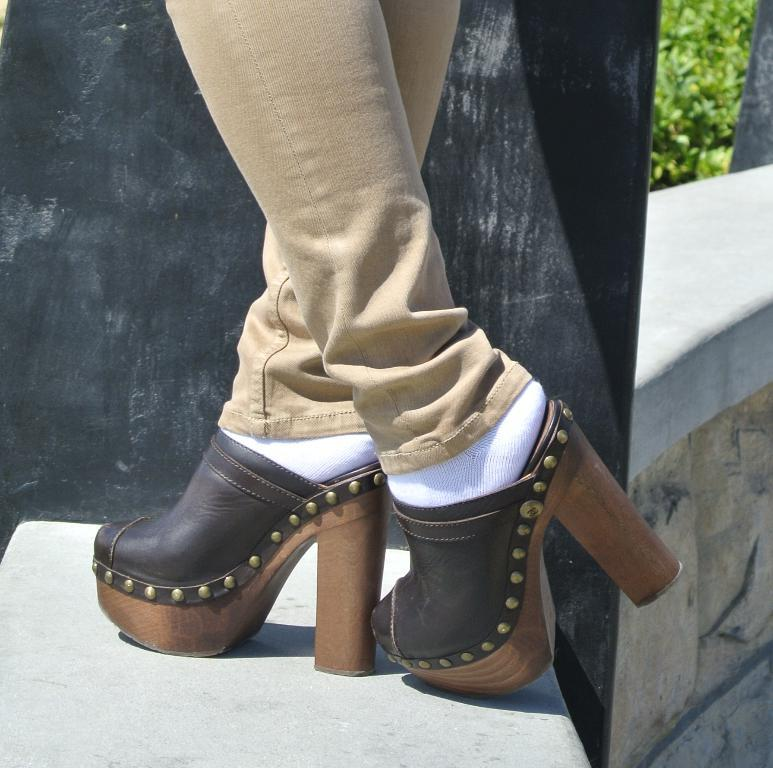What part of a person can be seen in the image? There are legs of a person in the image. What is the surface beneath the person's legs? The ground is visible in the image. What color is the black colored object in the image? The black colored object in the image is black. What type of vegetation is visible in the image? There is grass visible in the image. How does the person in the image attract the attention of zinc particles? There is no mention of zinc particles or attracting attention in the image. 